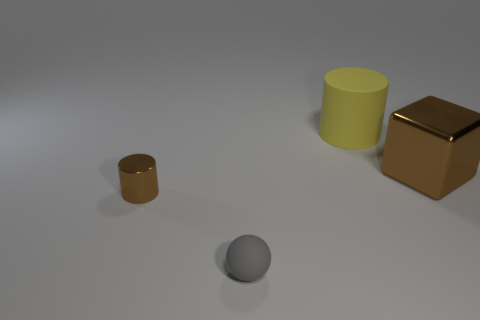How many objects are either big things that are to the left of the big brown thing or small blue spheres?
Offer a terse response. 1. Are any small brown metal cylinders visible?
Give a very brief answer. Yes. There is a cylinder left of the tiny gray sphere; what is it made of?
Give a very brief answer. Metal. There is a large object that is the same color as the tiny metallic thing; what material is it?
Give a very brief answer. Metal. What number of small things are brown metal blocks or brown spheres?
Your answer should be very brief. 0. The small matte ball has what color?
Give a very brief answer. Gray. There is a metallic thing that is right of the gray rubber object; are there any tiny matte spheres that are right of it?
Your answer should be very brief. No. Are there fewer gray balls in front of the small matte object than tiny brown metallic cylinders?
Your response must be concise. Yes. Does the tiny object in front of the tiny cylinder have the same material as the cube?
Your answer should be compact. No. What is the color of the object that is the same material as the tiny gray ball?
Offer a very short reply. Yellow. 